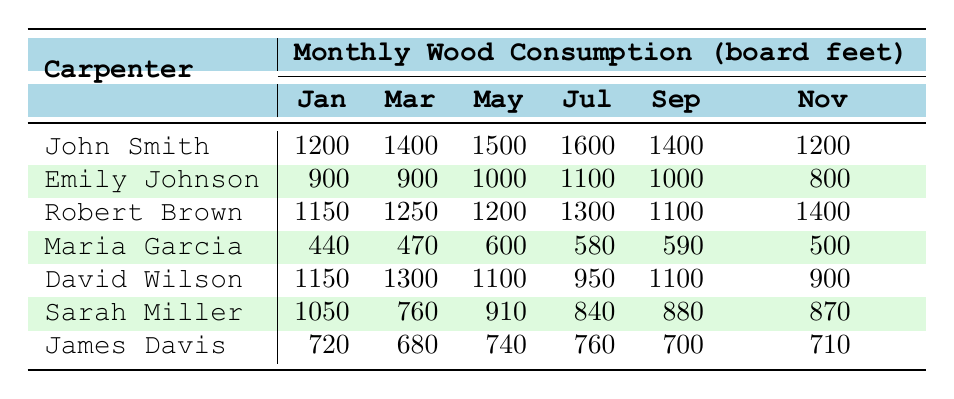What is the total wood consumption for John Smith in January? John Smith's wood consumption in January is listed as 1200 board feet.
Answer: 1200 Which carpenter had the highest wood consumption in May? In May, John Smith had the highest consumption at 1500 board feet, compared to others: Emily Johnson (1000), Robert Brown (1200), Maria Garcia (600), David Wilson (1100), Sarah Miller (910), and James Davis (740).
Answer: John Smith What is the average wood consumption for Robert Brown across the given months? Robert Brown's consumptions for the given months are: January (1150), March (1250), May (1200), July (1300), September (1100), and November (1400). Adding these gives 1150 + 1250 + 1200 + 1300 + 1100 + 1400 = 8400. Dividing by 6 gives an average of 8400 / 6 = 1400.
Answer: 1400 Did Maria Garcia consume more wood than David Wilson in any month? In January, Maria Garcia consumed 440 and David Wilson 1150. In March, it was 470 vs. 1300. In May, Maria consumed 600 compared to David's 1100. In July, Maria had 580 vs. David's 950. In September, Maria consumed 590 against David's 1100, and in November, it was 500 vs. 900. In every month, David Wilson consumed more wood.
Answer: No What is the difference between John Smith’s consumption in July and September? John Smith consumed 1600 board feet in July and 1400 in September. The difference is calculated as 1600 - 1400 = 200.
Answer: 200 Who had the lowest wood consumption in November? In November, the wood consumptions for all carpenters are: John Smith (1200), Emily Johnson (800), Robert Brown (1400), Maria Garcia (500), David Wilson (900), Sarah Miller (870), and James Davis (710). The lowest is Maria Garcia at 500 board feet.
Answer: Maria Garcia Which carpenter had consistent wood consumption across the months? Looking at the table, James Davis's consumption varies from 720, 680, 740, 760, 700, to 710 showing inconsistency. Every other carpenter shows variation in their consumption levels. Therefore, no carpenter had consistent consumption.
Answer: No What is the total wood consumption for all carpenters in March? The total wood consumption for March is: John Smith (1400) + Emily Johnson (900) + Robert Brown (1250) + Maria Garcia (470) + David Wilson (1300) + Sarah Miller (760) + James Davis (680) = 5760 board feet.
Answer: 5760 Which carpenter increased their wood consumption the most from January to August? Comparing each month, John Smith increased from 1200 (January) to 1700 (August), a change of 500. Other carpenters were checked and John Smith had the largest increase.
Answer: John Smith What was Sarah Miller's average consumption over the months listed? Sarah Miller's consumptions are: January (1050), March (760), May (910), July (840), September (880), and November (870). Total is 1050 + 760 + 910 + 840 + 880 + 870 = 5310, which gives an average of 5310 / 6 = 885.
Answer: 885 